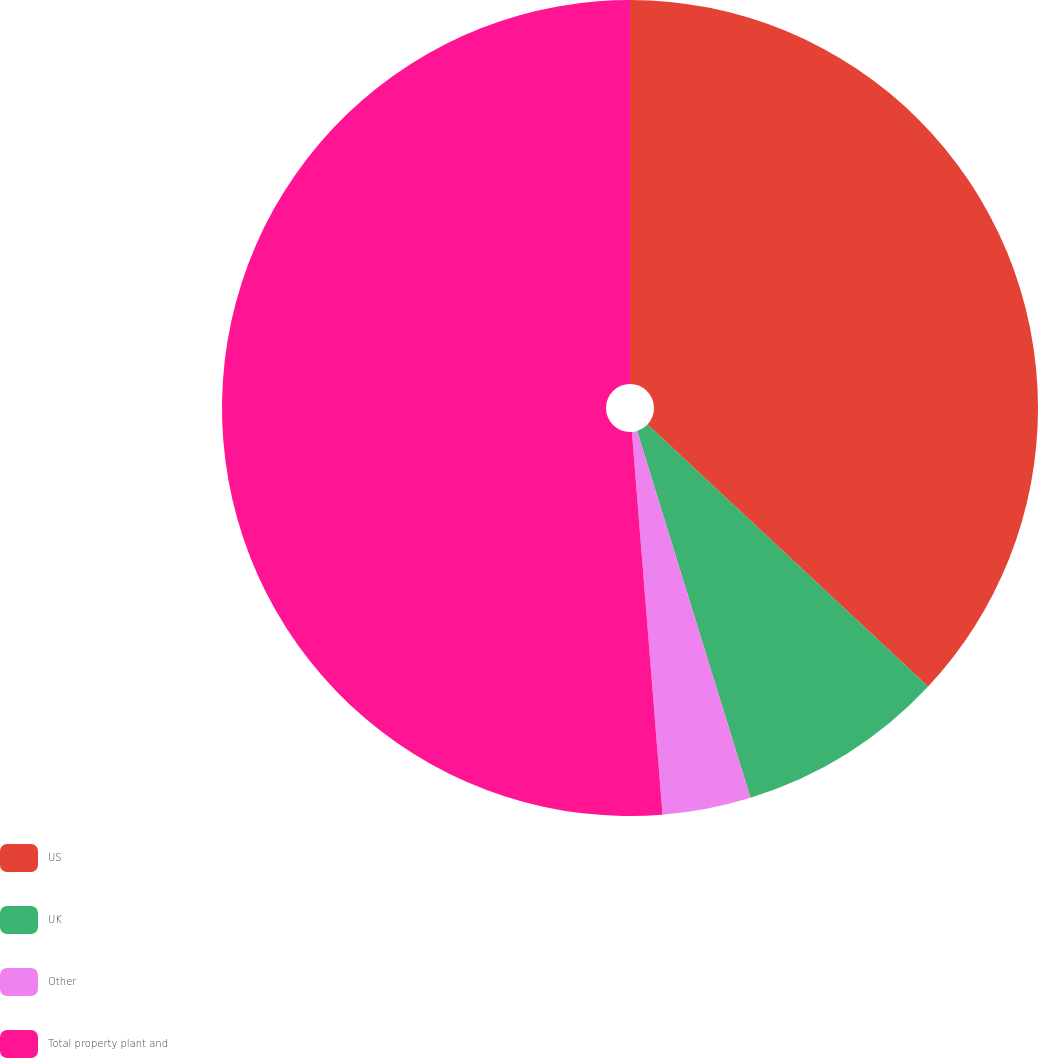Convert chart to OTSL. <chart><loc_0><loc_0><loc_500><loc_500><pie_chart><fcel>US<fcel>UK<fcel>Other<fcel>Total property plant and<nl><fcel>36.96%<fcel>8.27%<fcel>3.5%<fcel>51.27%<nl></chart> 